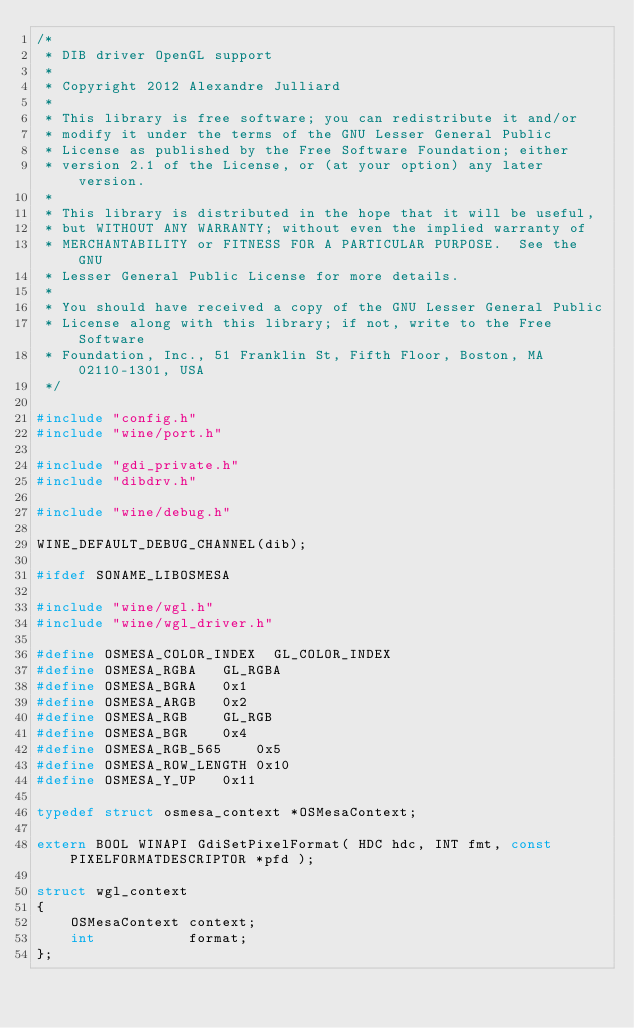<code> <loc_0><loc_0><loc_500><loc_500><_C_>/*
 * DIB driver OpenGL support
 *
 * Copyright 2012 Alexandre Julliard
 *
 * This library is free software; you can redistribute it and/or
 * modify it under the terms of the GNU Lesser General Public
 * License as published by the Free Software Foundation; either
 * version 2.1 of the License, or (at your option) any later version.
 *
 * This library is distributed in the hope that it will be useful,
 * but WITHOUT ANY WARRANTY; without even the implied warranty of
 * MERCHANTABILITY or FITNESS FOR A PARTICULAR PURPOSE.  See the GNU
 * Lesser General Public License for more details.
 *
 * You should have received a copy of the GNU Lesser General Public
 * License along with this library; if not, write to the Free Software
 * Foundation, Inc., 51 Franklin St, Fifth Floor, Boston, MA 02110-1301, USA
 */

#include "config.h"
#include "wine/port.h"

#include "gdi_private.h"
#include "dibdrv.h"

#include "wine/debug.h"

WINE_DEFAULT_DEBUG_CHANNEL(dib);

#ifdef SONAME_LIBOSMESA

#include "wine/wgl.h"
#include "wine/wgl_driver.h"

#define OSMESA_COLOR_INDEX	GL_COLOR_INDEX
#define OSMESA_RGBA		GL_RGBA
#define OSMESA_BGRA		0x1
#define OSMESA_ARGB		0x2
#define OSMESA_RGB		GL_RGB
#define OSMESA_BGR		0x4
#define OSMESA_RGB_565		0x5
#define OSMESA_ROW_LENGTH	0x10
#define OSMESA_Y_UP		0x11

typedef struct osmesa_context *OSMesaContext;

extern BOOL WINAPI GdiSetPixelFormat( HDC hdc, INT fmt, const PIXELFORMATDESCRIPTOR *pfd );

struct wgl_context
{
    OSMesaContext context;
    int           format;
};
</code> 